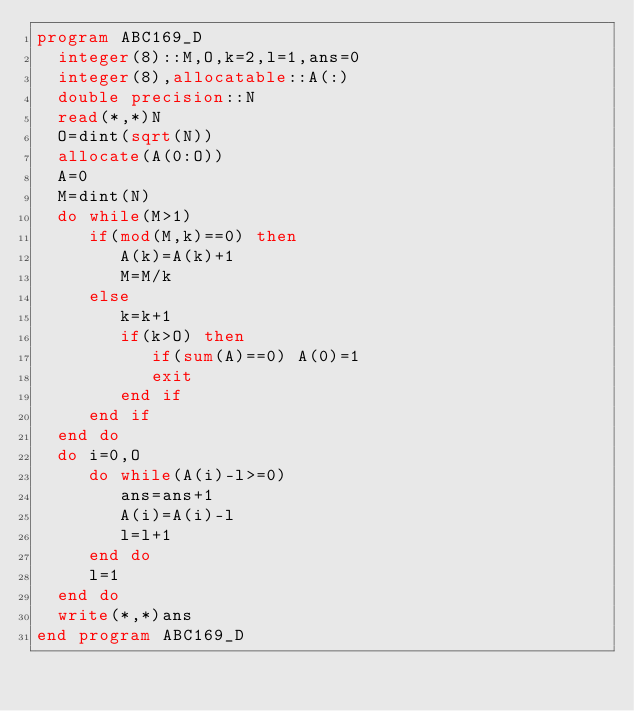Convert code to text. <code><loc_0><loc_0><loc_500><loc_500><_FORTRAN_>program ABC169_D
  integer(8)::M,O,k=2,l=1,ans=0
  integer(8),allocatable::A(:)
  double precision::N
  read(*,*)N
  O=dint(sqrt(N))
  allocate(A(0:O))
  A=0
  M=dint(N)
  do while(M>1)
     if(mod(M,k)==0) then
        A(k)=A(k)+1
        M=M/k
     else
        k=k+1
        if(k>O) then
           if(sum(A)==0) A(0)=1
           exit
        end if
     end if
  end do
  do i=0,O
     do while(A(i)-l>=0)
        ans=ans+1
        A(i)=A(i)-l
        l=l+1
     end do
     l=1
  end do
  write(*,*)ans
end program ABC169_D</code> 